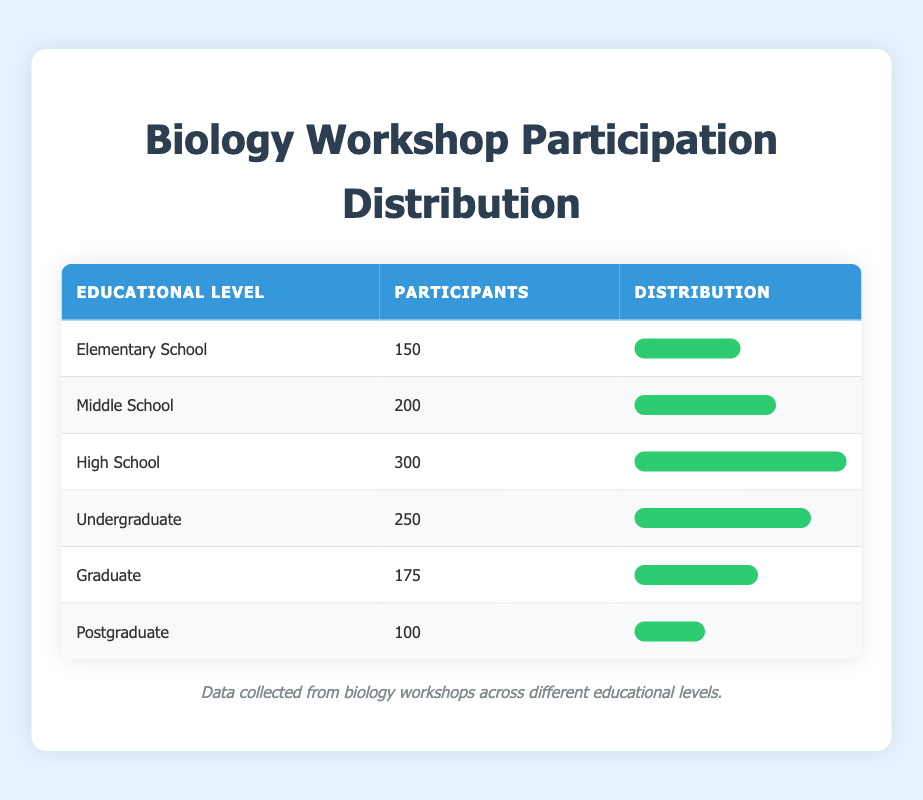What is the total number of participants across all educational levels? To find the total number of participants, we need to sum the participants from each educational level: 150 (Elementary) + 200 (Middle) + 300 (High School) + 250 (Undergraduate) + 175 (Graduate) + 100 (Postgraduate) = 1175.
Answer: 1175 Which educational level has the highest number of participants? By analyzing the table, High School has the highest number of participants with 300, which is greater than any other educational level.
Answer: High School What is the average number of participants per educational level? There are 6 educational levels in total. Summing the participants gives us 1175. To find the average, we divide 1175 by 6, which equals approximately 195.83.
Answer: 195.83 Is the number of participants in Postgraduate equal to any other educational level? By comparing the participants, Postgraduate has 100 participants, which is not equal to any other educational level in the table.
Answer: No How many more participants are there in Undergraduate than in Graduate? To find the difference, we need to subtract the number of Graduate participants (175) from the number of Undergraduate participants (250). So, 250 - 175 = 75.
Answer: 75 What percentage of participants are from High School? To find the percentage of High School participants, we take the number of High School participants (300), divide by the total number of participants (1175), and multiply by 100. This gives us approximately 25.53%.
Answer: 25.53% Is the number of participants in Middle School greater than that in Elementary School? Comparing the numbers shows Middle School has 200 participants, which is indeed greater than Elementary School's 150 participants.
Answer: Yes What is the total number of participants from Elementary, Graduate, and Postgraduate levels? To find the total, we need to add the participants from each of these educational levels: 150 (Elementary) + 175 (Graduate) + 100 (Postgraduate) equals 425.
Answer: 425 How does the number of participants in the Graduate level compare to that in Middle School? Comparing the two, Graduate has 175 participants while Middle School has 200. Therefore, Graduate has fewer participants than Middle School.
Answer: Graduate has fewer participants 